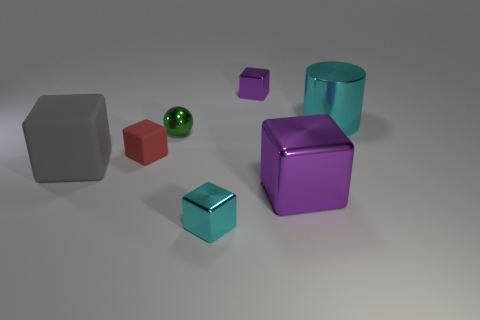Subtract all red blocks. How many blocks are left? 4 Subtract all red cubes. How many cubes are left? 4 Subtract all green blocks. Subtract all green cylinders. How many blocks are left? 5 Add 2 small cyan shiny blocks. How many objects exist? 9 Subtract all spheres. How many objects are left? 6 Subtract 0 purple cylinders. How many objects are left? 7 Subtract all gray metallic blocks. Subtract all red rubber blocks. How many objects are left? 6 Add 6 big gray cubes. How many big gray cubes are left? 7 Add 6 cyan cylinders. How many cyan cylinders exist? 7 